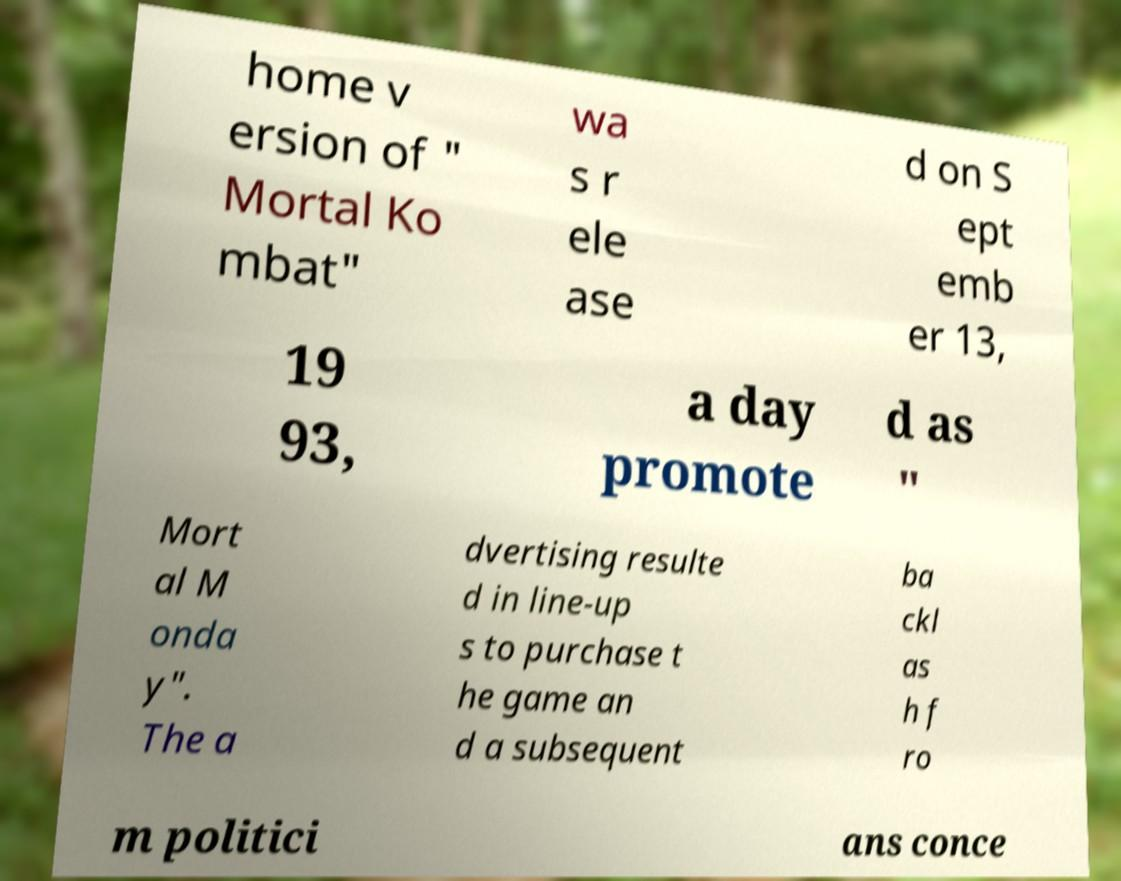I need the written content from this picture converted into text. Can you do that? home v ersion of " Mortal Ko mbat" wa s r ele ase d on S ept emb er 13, 19 93, a day promote d as " Mort al M onda y". The a dvertising resulte d in line-up s to purchase t he game an d a subsequent ba ckl as h f ro m politici ans conce 